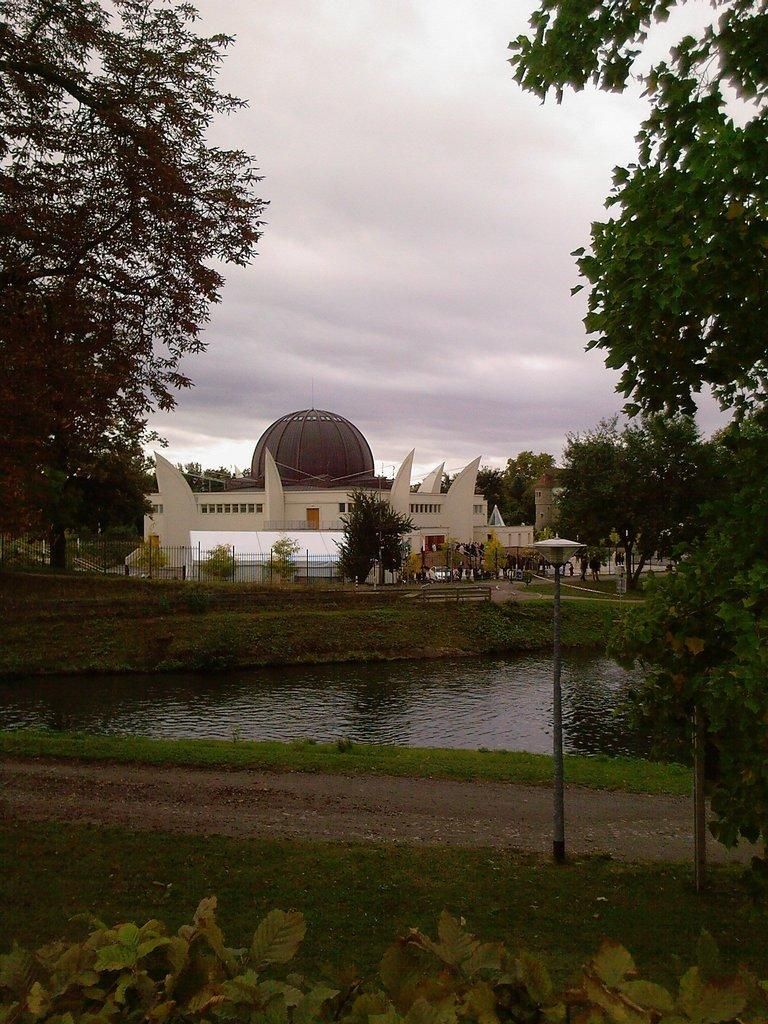What type of structure is in the image? There is a complex in the image. What is located in front of the complex? There is a lake in front of the complex. What can be seen around the lake? There are trees around the lake. What is visible in the background of the image? The sky is visible in the background of the image. What type of finger can be seen in the image? There is no finger present in the image. What type of eggnog is being served at the complex in the image? There is no mention of eggnog or any food or beverage in the image. 